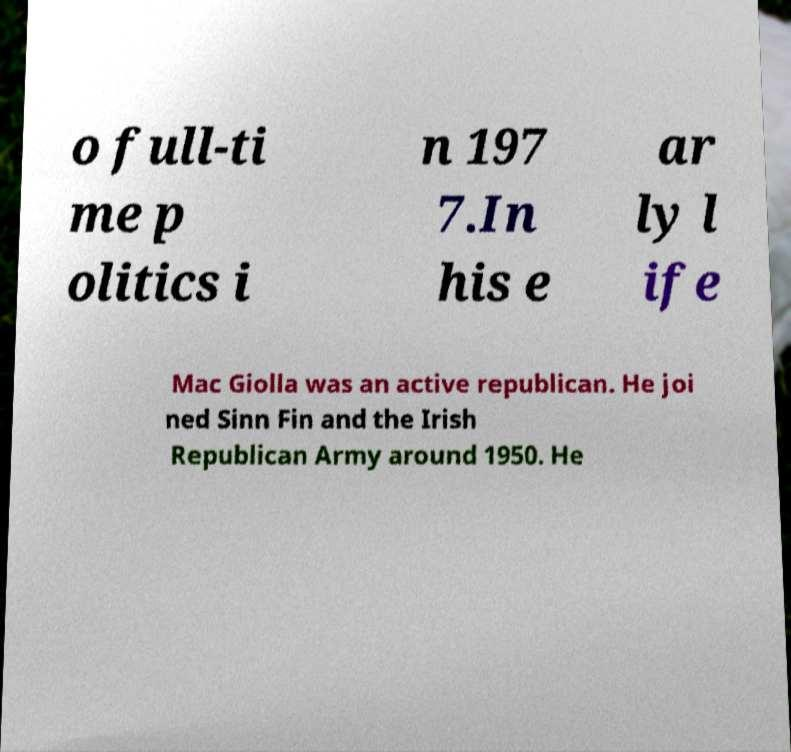For documentation purposes, I need the text within this image transcribed. Could you provide that? o full-ti me p olitics i n 197 7.In his e ar ly l ife Mac Giolla was an active republican. He joi ned Sinn Fin and the Irish Republican Army around 1950. He 